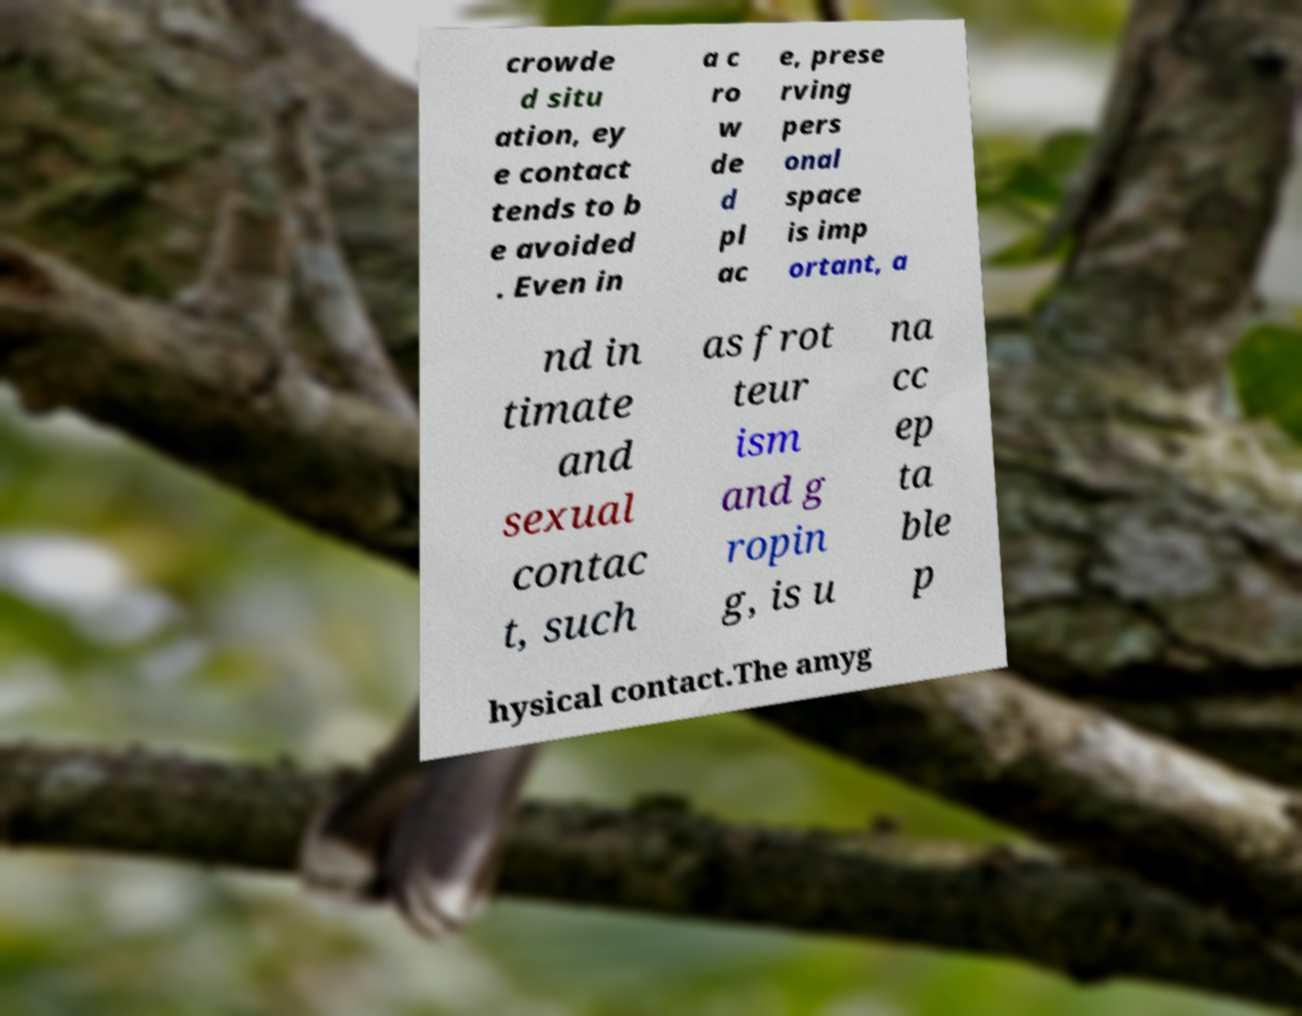What messages or text are displayed in this image? I need them in a readable, typed format. crowde d situ ation, ey e contact tends to b e avoided . Even in a c ro w de d pl ac e, prese rving pers onal space is imp ortant, a nd in timate and sexual contac t, such as frot teur ism and g ropin g, is u na cc ep ta ble p hysical contact.The amyg 